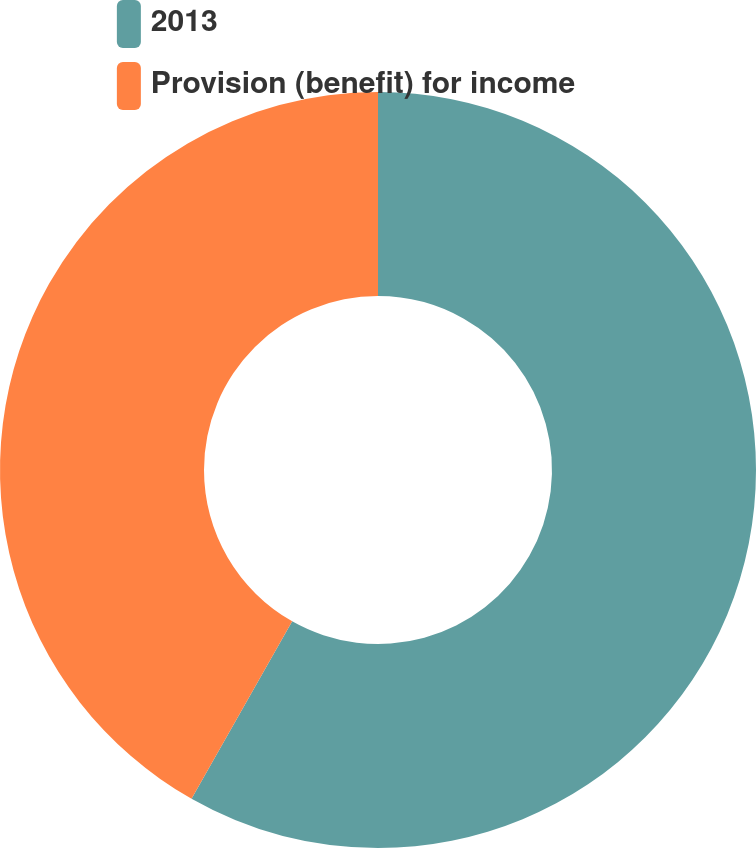Convert chart. <chart><loc_0><loc_0><loc_500><loc_500><pie_chart><fcel>2013<fcel>Provision (benefit) for income<nl><fcel>58.21%<fcel>41.79%<nl></chart> 